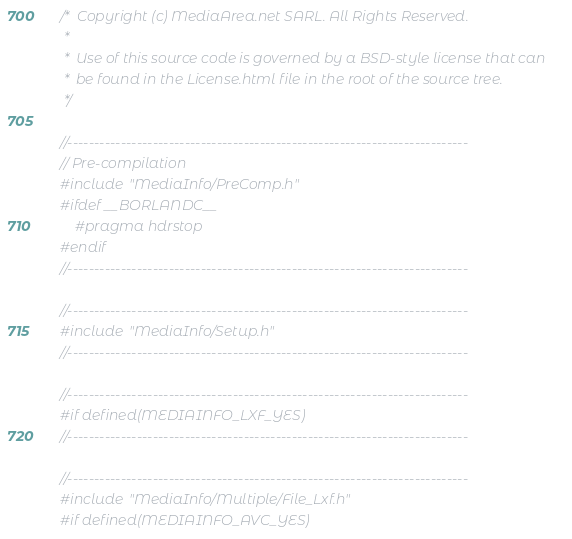Convert code to text. <code><loc_0><loc_0><loc_500><loc_500><_C++_>/*  Copyright (c) MediaArea.net SARL. All Rights Reserved.
 *
 *  Use of this source code is governed by a BSD-style license that can
 *  be found in the License.html file in the root of the source tree.
 */

//---------------------------------------------------------------------------
// Pre-compilation
#include "MediaInfo/PreComp.h"
#ifdef __BORLANDC__
    #pragma hdrstop
#endif
//---------------------------------------------------------------------------

//---------------------------------------------------------------------------
#include "MediaInfo/Setup.h"
//---------------------------------------------------------------------------

//---------------------------------------------------------------------------
#if defined(MEDIAINFO_LXF_YES)
//---------------------------------------------------------------------------

//---------------------------------------------------------------------------
#include "MediaInfo/Multiple/File_Lxf.h"
#if defined(MEDIAINFO_AVC_YES)</code> 